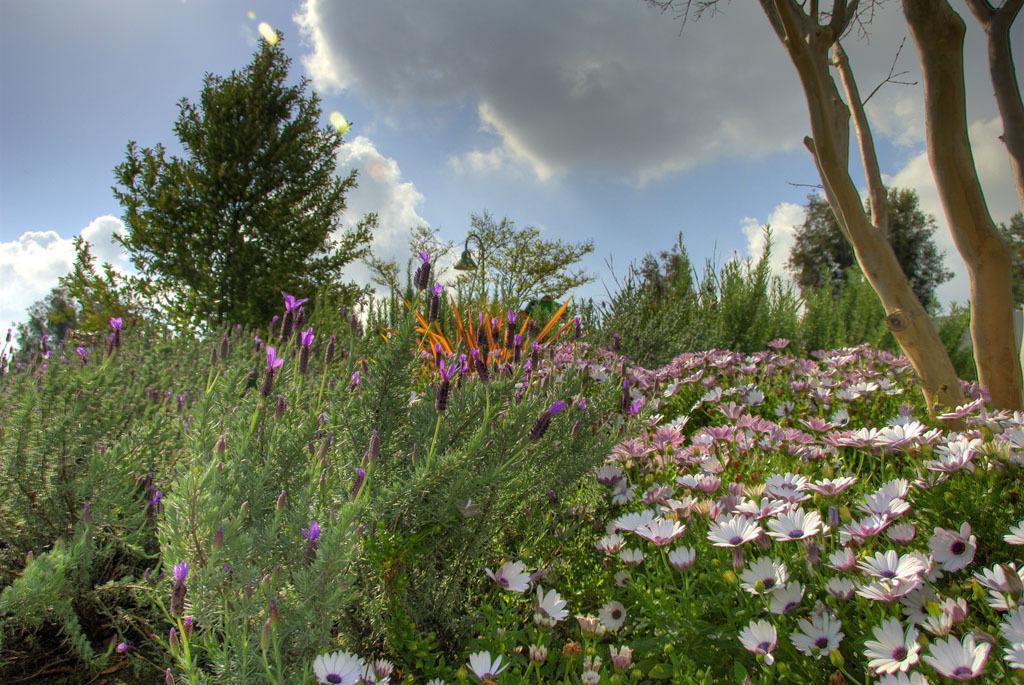What type of vegetation can be seen in the image? There are trees in the image. What other natural elements are present in the image? There are flowers in the image. What can be seen in the background of the image? The sky is visible in the background of the image. What type of monkey can be seen eating dinner in the image? There is no monkey or dinner present in the image; it features trees, flowers, and the sky. 